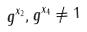Convert formula to latex. <formula><loc_0><loc_0><loc_500><loc_500>g ^ { x _ { 2 } } , g ^ { x _ { 4 } } \ne 1</formula> 